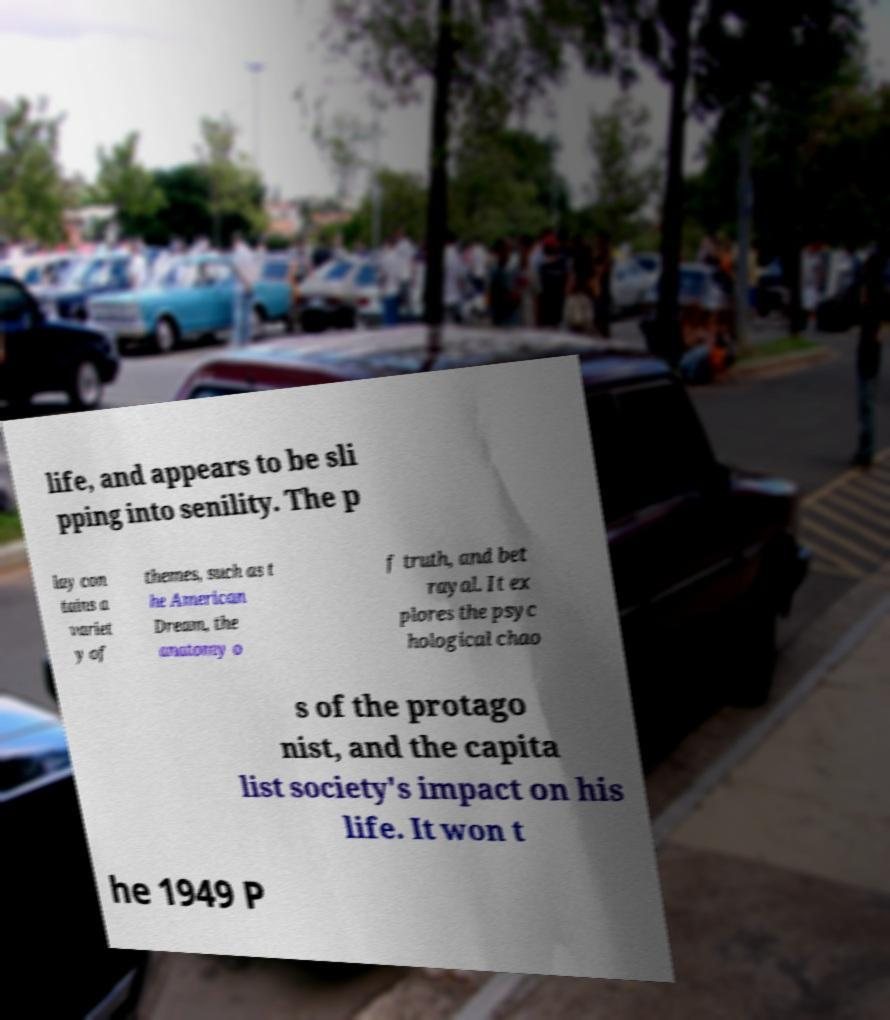Please identify and transcribe the text found in this image. life, and appears to be sli pping into senility. The p lay con tains a variet y of themes, such as t he American Dream, the anatomy o f truth, and bet rayal. It ex plores the psyc hological chao s of the protago nist, and the capita list society's impact on his life. It won t he 1949 P 